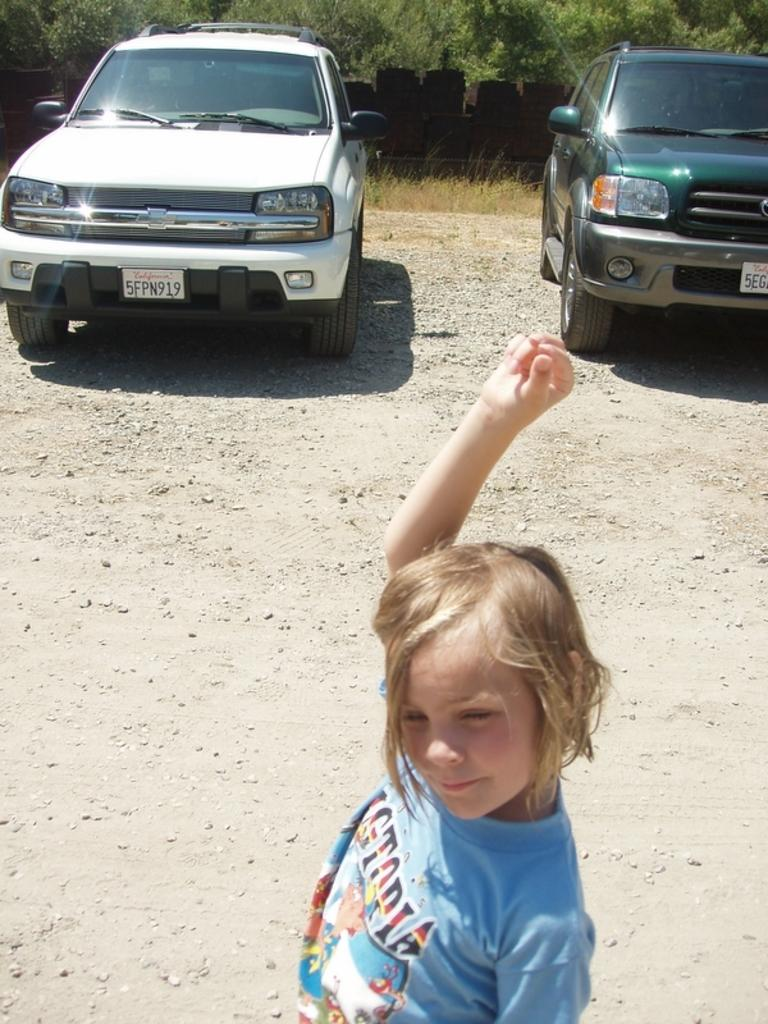Who is the main subject in the image? There is a girl in the image. What is the girl doing in the image? The girl is standing. What is the girl wearing in the image? The girl is wearing a blue t-shirt. What can be seen on the left side of the image? There is a white car on the left side of the image. What can be seen on the right side of the image? There is a green car on the right side of the image. What type of lamp is hanging from the girl's skin in the image? There is no lamp present in the image, nor is there any indication that the girl's skin is involved. 